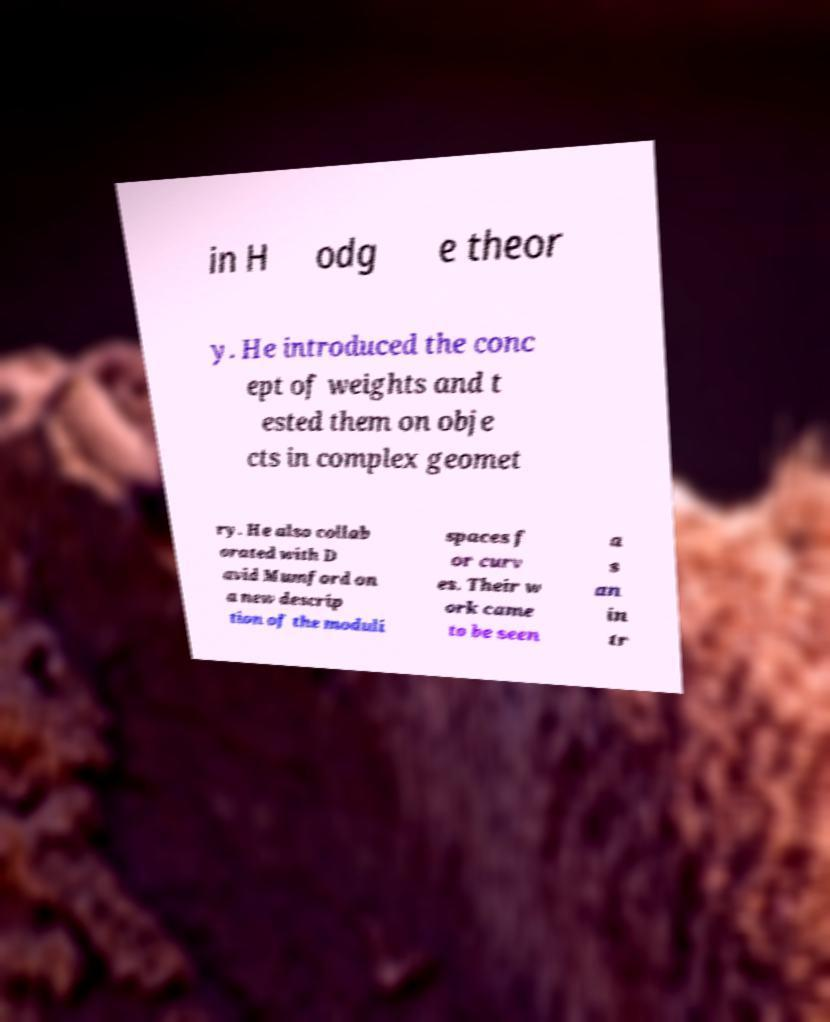Could you extract and type out the text from this image? in H odg e theor y. He introduced the conc ept of weights and t ested them on obje cts in complex geomet ry. He also collab orated with D avid Mumford on a new descrip tion of the moduli spaces f or curv es. Their w ork came to be seen a s an in tr 